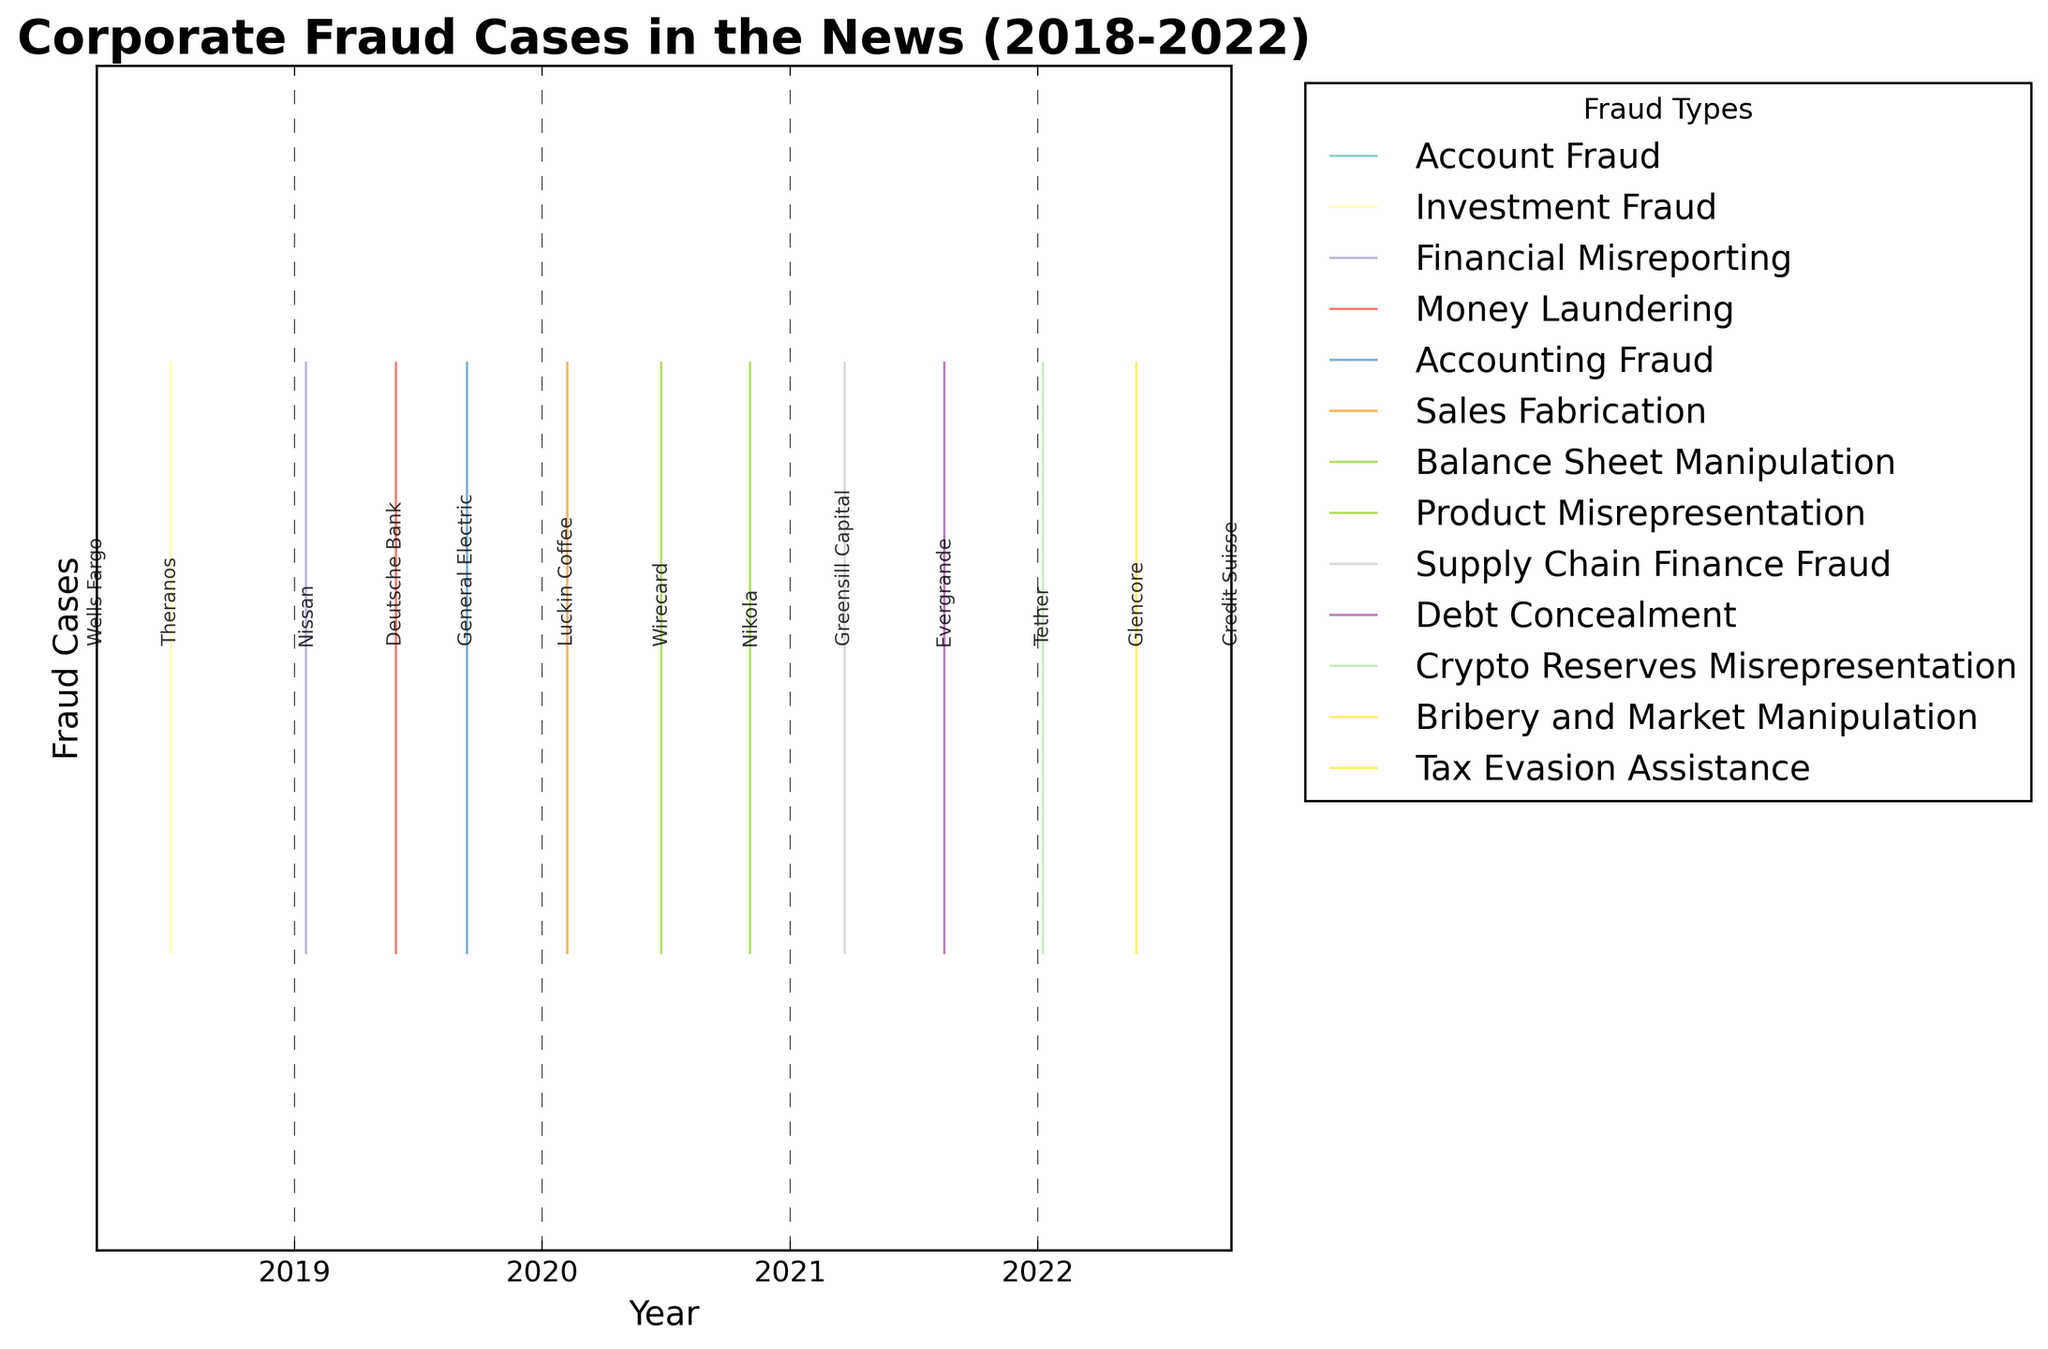What is the title of the plot? The title of the plot is usually found at the top, displaying the main subject of the visualization. The title in this plot is "Corporate Fraud Cases in the News (2018-2022)"
Answer: Corporate Fraud Cases in the News (2018-2022) How many different fraud types are represented in the plot? Look at the legend on the right-hand side of the plot, which shows the different categories of fraud types. There are multiple colors, each corresponding to a different fraud type. Count these entries.
Answer: 10 Which fraud type had the first reported case in 2020? Check the data points and the corresponding annotations to identify the fraud type that had its first appearance in 2020. The x-axis shows the timeline, so find the earliest point on this axis for 2020.
Answer: Sales Fabrication How frequently were fraud cases reported in the years 2020 and 2021 combined? Count the number of events (data points) plotted for the years 2020 and 2021 by visually scanning the respective segments on the x-axis.
Answer: 5 Which company had a fraud case involving Bribery and Market Manipulation and in what year? Refer to the annotations linked to the event lines. Find the label "Glencore" and note the color associated with "Bribery and Market Manipulation." Check the x-axis for the corresponding year.
Answer: Glencore, 2022 Is there a trend in the frequency of fraud cases reported from 2018 to 2022? To discern a trend, look at the density and distribution of data points across the years. A higher number of points indicates more frequent reporting. Visualize this trend from the start year to the end year.
Answer: Yes, there is an increasing trend Which company was involved in balance sheet manipulation? Look for the event annotated with the company's name and find the label that matches the fraud type "Balance Sheet Manipulation."
Answer: Wirecard Were there any fraud cases reported by The Guardian? If so, what type? Identify the publication names associated with each annotation. Locate "The Guardian" and note the associated fraud type from its position.
Answer: Yes, Tax Evasion Assistance Which year had the highest number of unique fraud cases? Scan the x-axis, counting the number of unique events (annotated points) for each year. Compare to find the year with the most entries.
Answer: 2022 What are the types of fraud reported in the first and last years of the data range? Check the event points at the beginning (2018) and the end (2022) of the x-axis. Note the types of fraud listed in these years by looking at the annotations and their associated colors.
Answer: Account Fraud in 2018, Tax Evasion Assistance in 2022 